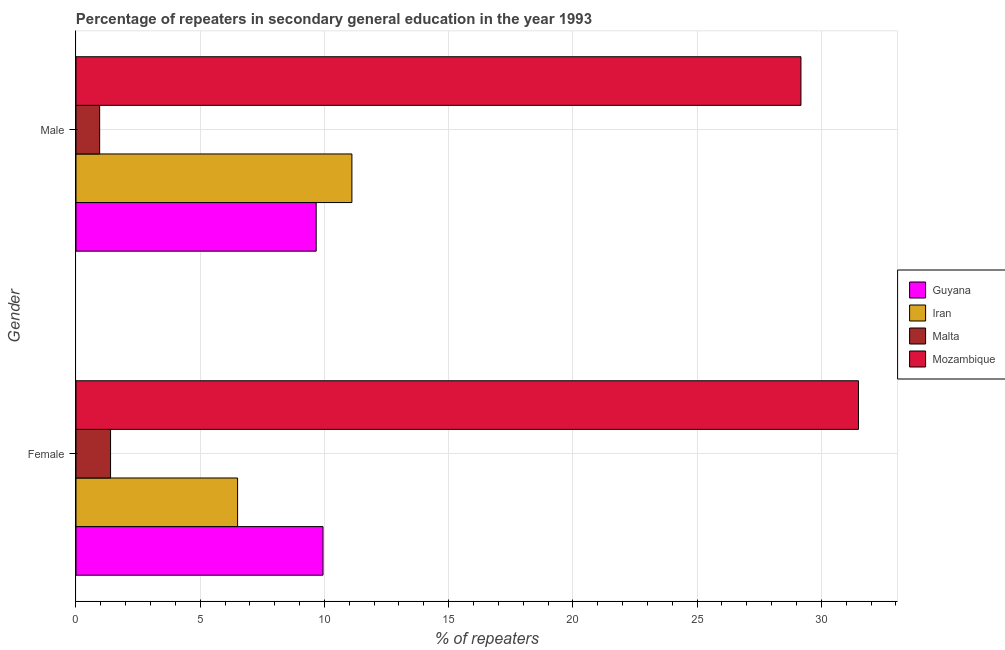Are the number of bars per tick equal to the number of legend labels?
Your response must be concise. Yes. How many bars are there on the 2nd tick from the top?
Your response must be concise. 4. How many bars are there on the 1st tick from the bottom?
Your answer should be compact. 4. What is the label of the 2nd group of bars from the top?
Offer a very short reply. Female. What is the percentage of female repeaters in Iran?
Provide a succinct answer. 6.5. Across all countries, what is the maximum percentage of male repeaters?
Ensure brevity in your answer.  29.18. Across all countries, what is the minimum percentage of female repeaters?
Ensure brevity in your answer.  1.39. In which country was the percentage of female repeaters maximum?
Provide a succinct answer. Mozambique. In which country was the percentage of male repeaters minimum?
Make the answer very short. Malta. What is the total percentage of male repeaters in the graph?
Your response must be concise. 50.9. What is the difference between the percentage of female repeaters in Iran and that in Guyana?
Give a very brief answer. -3.44. What is the difference between the percentage of male repeaters in Iran and the percentage of female repeaters in Mozambique?
Provide a succinct answer. -20.39. What is the average percentage of female repeaters per country?
Provide a succinct answer. 12.33. What is the difference between the percentage of male repeaters and percentage of female repeaters in Iran?
Make the answer very short. 4.6. In how many countries, is the percentage of female repeaters greater than 21 %?
Your response must be concise. 1. What is the ratio of the percentage of male repeaters in Mozambique to that in Iran?
Ensure brevity in your answer.  2.63. Is the percentage of male repeaters in Iran less than that in Guyana?
Your answer should be compact. No. In how many countries, is the percentage of male repeaters greater than the average percentage of male repeaters taken over all countries?
Your answer should be very brief. 1. What does the 3rd bar from the top in Male represents?
Provide a short and direct response. Iran. What does the 1st bar from the bottom in Female represents?
Your answer should be very brief. Guyana. How many bars are there?
Your response must be concise. 8. What is the difference between two consecutive major ticks on the X-axis?
Offer a terse response. 5. Does the graph contain any zero values?
Make the answer very short. No. What is the title of the graph?
Ensure brevity in your answer.  Percentage of repeaters in secondary general education in the year 1993. Does "Slovenia" appear as one of the legend labels in the graph?
Provide a short and direct response. No. What is the label or title of the X-axis?
Provide a succinct answer. % of repeaters. What is the % of repeaters in Guyana in Female?
Offer a very short reply. 9.94. What is the % of repeaters of Iran in Female?
Offer a very short reply. 6.5. What is the % of repeaters of Malta in Female?
Your answer should be very brief. 1.39. What is the % of repeaters of Mozambique in Female?
Ensure brevity in your answer.  31.49. What is the % of repeaters of Guyana in Male?
Provide a succinct answer. 9.67. What is the % of repeaters of Iran in Male?
Provide a short and direct response. 11.11. What is the % of repeaters in Malta in Male?
Your response must be concise. 0.95. What is the % of repeaters in Mozambique in Male?
Provide a succinct answer. 29.18. Across all Gender, what is the maximum % of repeaters of Guyana?
Your response must be concise. 9.94. Across all Gender, what is the maximum % of repeaters in Iran?
Provide a short and direct response. 11.11. Across all Gender, what is the maximum % of repeaters of Malta?
Make the answer very short. 1.39. Across all Gender, what is the maximum % of repeaters in Mozambique?
Your answer should be very brief. 31.49. Across all Gender, what is the minimum % of repeaters in Guyana?
Offer a very short reply. 9.67. Across all Gender, what is the minimum % of repeaters in Iran?
Provide a short and direct response. 6.5. Across all Gender, what is the minimum % of repeaters of Malta?
Your answer should be compact. 0.95. Across all Gender, what is the minimum % of repeaters of Mozambique?
Provide a short and direct response. 29.18. What is the total % of repeaters in Guyana in the graph?
Keep it short and to the point. 19.61. What is the total % of repeaters of Iran in the graph?
Your answer should be compact. 17.61. What is the total % of repeaters of Malta in the graph?
Your response must be concise. 2.34. What is the total % of repeaters in Mozambique in the graph?
Provide a succinct answer. 60.67. What is the difference between the % of repeaters in Guyana in Female and that in Male?
Your response must be concise. 0.28. What is the difference between the % of repeaters of Iran in Female and that in Male?
Provide a short and direct response. -4.6. What is the difference between the % of repeaters of Malta in Female and that in Male?
Ensure brevity in your answer.  0.44. What is the difference between the % of repeaters in Mozambique in Female and that in Male?
Give a very brief answer. 2.31. What is the difference between the % of repeaters in Guyana in Female and the % of repeaters in Iran in Male?
Provide a short and direct response. -1.16. What is the difference between the % of repeaters of Guyana in Female and the % of repeaters of Malta in Male?
Provide a short and direct response. 8.99. What is the difference between the % of repeaters of Guyana in Female and the % of repeaters of Mozambique in Male?
Keep it short and to the point. -19.24. What is the difference between the % of repeaters of Iran in Female and the % of repeaters of Malta in Male?
Keep it short and to the point. 5.55. What is the difference between the % of repeaters of Iran in Female and the % of repeaters of Mozambique in Male?
Your response must be concise. -22.67. What is the difference between the % of repeaters in Malta in Female and the % of repeaters in Mozambique in Male?
Your answer should be very brief. -27.79. What is the average % of repeaters of Guyana per Gender?
Give a very brief answer. 9.8. What is the average % of repeaters in Iran per Gender?
Keep it short and to the point. 8.8. What is the average % of repeaters of Malta per Gender?
Provide a short and direct response. 1.17. What is the average % of repeaters of Mozambique per Gender?
Give a very brief answer. 30.34. What is the difference between the % of repeaters in Guyana and % of repeaters in Iran in Female?
Ensure brevity in your answer.  3.44. What is the difference between the % of repeaters of Guyana and % of repeaters of Malta in Female?
Ensure brevity in your answer.  8.55. What is the difference between the % of repeaters of Guyana and % of repeaters of Mozambique in Female?
Give a very brief answer. -21.55. What is the difference between the % of repeaters in Iran and % of repeaters in Malta in Female?
Make the answer very short. 5.11. What is the difference between the % of repeaters in Iran and % of repeaters in Mozambique in Female?
Keep it short and to the point. -24.99. What is the difference between the % of repeaters of Malta and % of repeaters of Mozambique in Female?
Make the answer very short. -30.1. What is the difference between the % of repeaters in Guyana and % of repeaters in Iran in Male?
Give a very brief answer. -1.44. What is the difference between the % of repeaters in Guyana and % of repeaters in Malta in Male?
Provide a succinct answer. 8.71. What is the difference between the % of repeaters in Guyana and % of repeaters in Mozambique in Male?
Keep it short and to the point. -19.51. What is the difference between the % of repeaters of Iran and % of repeaters of Malta in Male?
Provide a short and direct response. 10.15. What is the difference between the % of repeaters in Iran and % of repeaters in Mozambique in Male?
Make the answer very short. -18.07. What is the difference between the % of repeaters of Malta and % of repeaters of Mozambique in Male?
Ensure brevity in your answer.  -28.23. What is the ratio of the % of repeaters of Guyana in Female to that in Male?
Your answer should be very brief. 1.03. What is the ratio of the % of repeaters in Iran in Female to that in Male?
Your answer should be compact. 0.59. What is the ratio of the % of repeaters in Malta in Female to that in Male?
Offer a very short reply. 1.46. What is the ratio of the % of repeaters of Mozambique in Female to that in Male?
Give a very brief answer. 1.08. What is the difference between the highest and the second highest % of repeaters of Guyana?
Give a very brief answer. 0.28. What is the difference between the highest and the second highest % of repeaters of Iran?
Make the answer very short. 4.6. What is the difference between the highest and the second highest % of repeaters of Malta?
Ensure brevity in your answer.  0.44. What is the difference between the highest and the second highest % of repeaters of Mozambique?
Your answer should be compact. 2.31. What is the difference between the highest and the lowest % of repeaters of Guyana?
Give a very brief answer. 0.28. What is the difference between the highest and the lowest % of repeaters of Iran?
Provide a short and direct response. 4.6. What is the difference between the highest and the lowest % of repeaters of Malta?
Make the answer very short. 0.44. What is the difference between the highest and the lowest % of repeaters in Mozambique?
Your answer should be very brief. 2.31. 